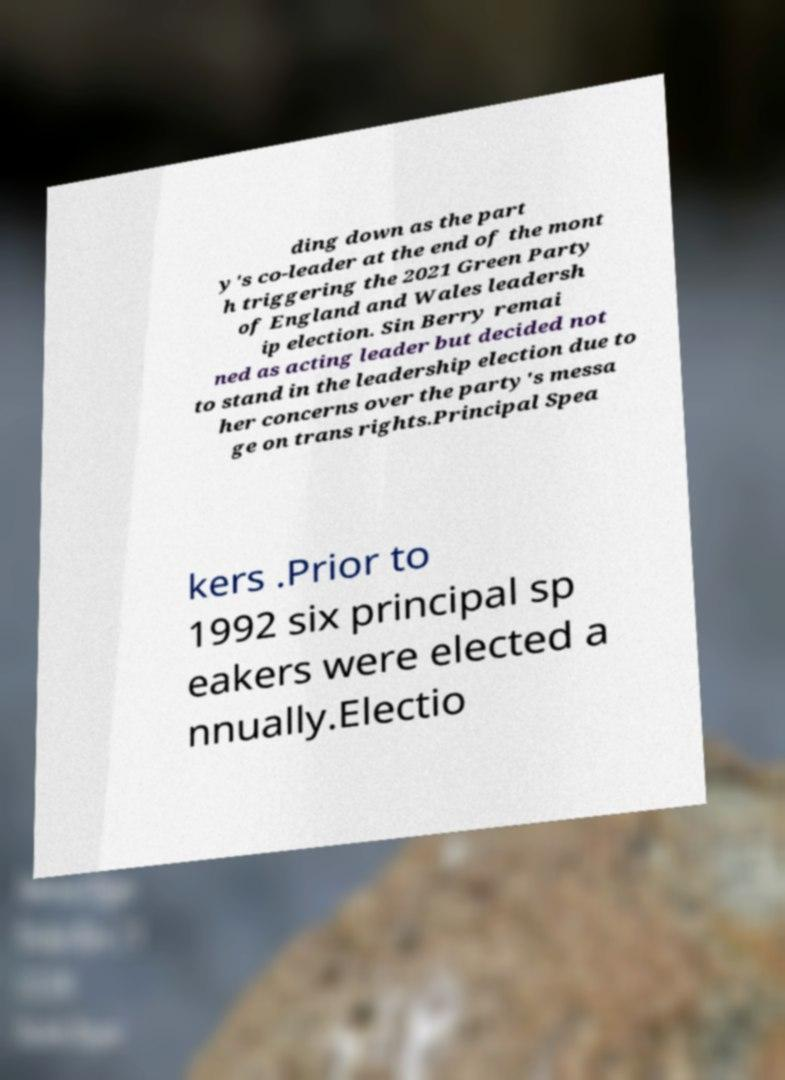Could you extract and type out the text from this image? ding down as the part y's co-leader at the end of the mont h triggering the 2021 Green Party of England and Wales leadersh ip election. Sin Berry remai ned as acting leader but decided not to stand in the leadership election due to her concerns over the party's messa ge on trans rights.Principal Spea kers .Prior to 1992 six principal sp eakers were elected a nnually.Electio 